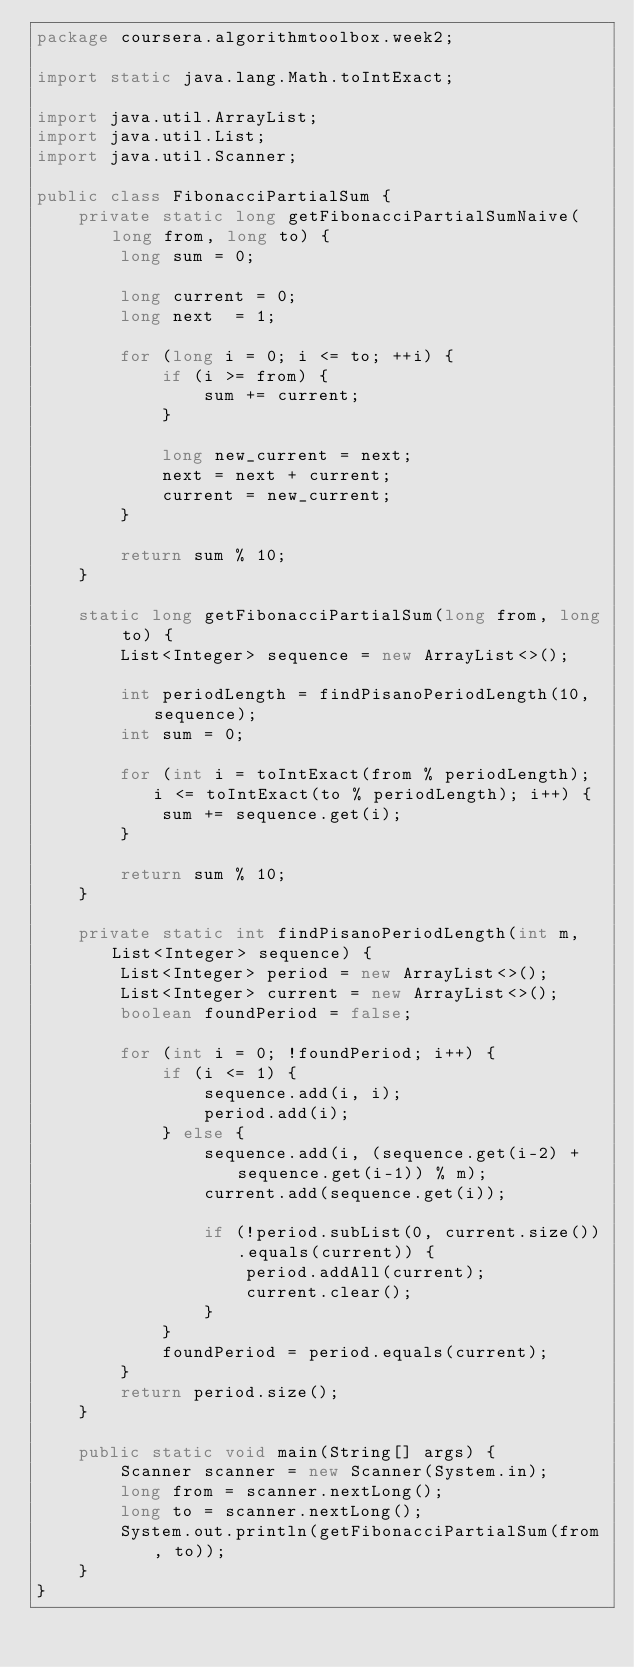<code> <loc_0><loc_0><loc_500><loc_500><_Java_>package coursera.algorithmtoolbox.week2;

import static java.lang.Math.toIntExact;

import java.util.ArrayList;
import java.util.List;
import java.util.Scanner;

public class FibonacciPartialSum {
    private static long getFibonacciPartialSumNaive(long from, long to) {
        long sum = 0;

        long current = 0;
        long next  = 1;

        for (long i = 0; i <= to; ++i) {
            if (i >= from) {
                sum += current;
            }

            long new_current = next;
            next = next + current;
            current = new_current;
        }

        return sum % 10;
    }

    static long getFibonacciPartialSum(long from, long to) {
        List<Integer> sequence = new ArrayList<>();

        int periodLength = findPisanoPeriodLength(10, sequence);
        int sum = 0;

        for (int i = toIntExact(from % periodLength); i <= toIntExact(to % periodLength); i++) {
            sum += sequence.get(i);
        }

        return sum % 10;
    }

    private static int findPisanoPeriodLength(int m, List<Integer> sequence) {
        List<Integer> period = new ArrayList<>();
        List<Integer> current = new ArrayList<>();
        boolean foundPeriod = false;

        for (int i = 0; !foundPeriod; i++) {
            if (i <= 1) {
                sequence.add(i, i);
                period.add(i);
            } else {
                sequence.add(i, (sequence.get(i-2) + sequence.get(i-1)) % m);
                current.add(sequence.get(i));

                if (!period.subList(0, current.size()).equals(current)) {
                    period.addAll(current);
                    current.clear();
                }
            }
            foundPeriod = period.equals(current);
        }
        return period.size();
    }

    public static void main(String[] args) {
        Scanner scanner = new Scanner(System.in);
        long from = scanner.nextLong();
        long to = scanner.nextLong();
        System.out.println(getFibonacciPartialSum(from, to));
    }
}

</code> 